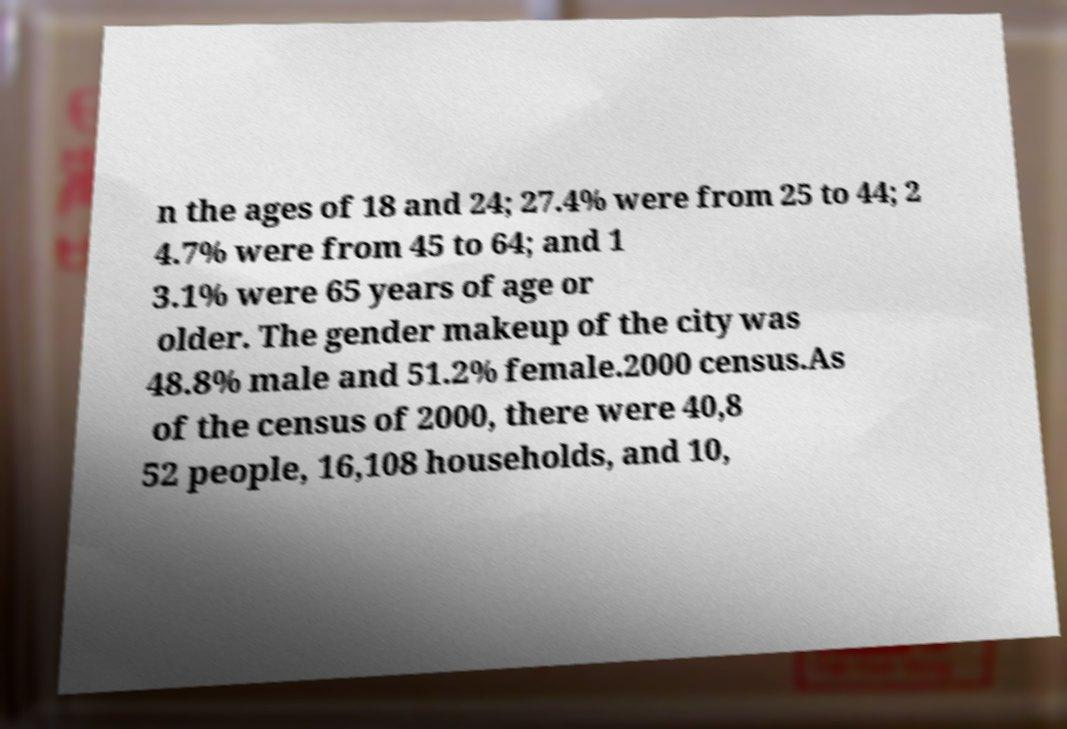Could you extract and type out the text from this image? n the ages of 18 and 24; 27.4% were from 25 to 44; 2 4.7% were from 45 to 64; and 1 3.1% were 65 years of age or older. The gender makeup of the city was 48.8% male and 51.2% female.2000 census.As of the census of 2000, there were 40,8 52 people, 16,108 households, and 10, 